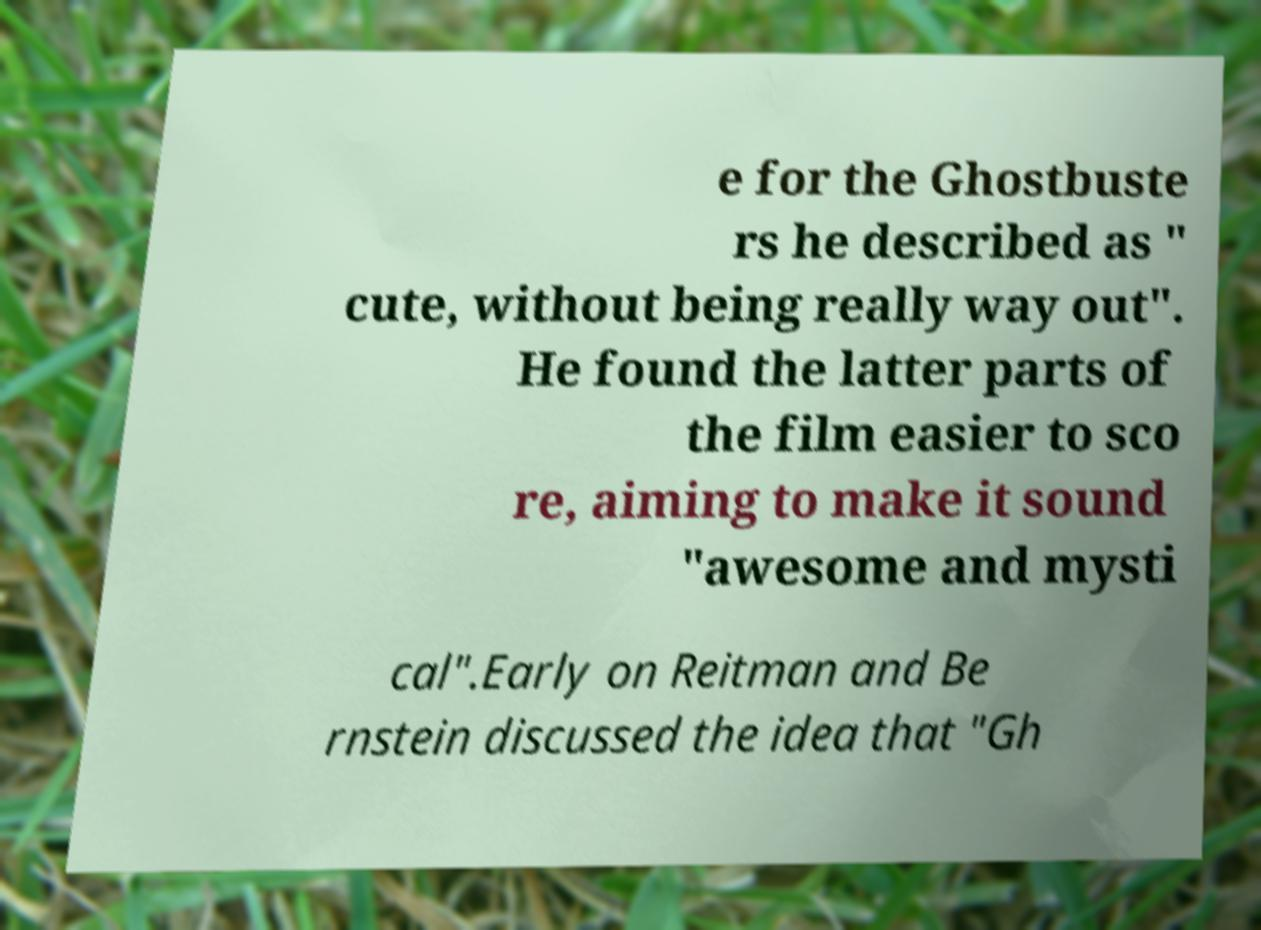I need the written content from this picture converted into text. Can you do that? e for the Ghostbuste rs he described as " cute, without being really way out". He found the latter parts of the film easier to sco re, aiming to make it sound "awesome and mysti cal".Early on Reitman and Be rnstein discussed the idea that "Gh 